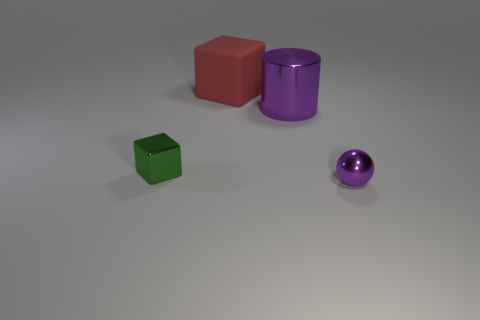Add 2 large objects. How many objects exist? 6 Subtract all balls. How many objects are left? 3 Add 3 small things. How many small things exist? 5 Subtract 0 yellow blocks. How many objects are left? 4 Subtract all tiny brown matte cubes. Subtract all small metallic balls. How many objects are left? 3 Add 2 balls. How many balls are left? 3 